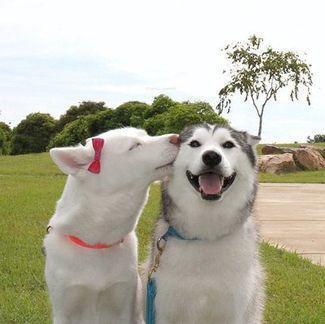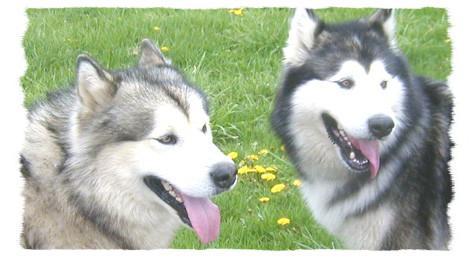The first image is the image on the left, the second image is the image on the right. Considering the images on both sides, is "The left and right image contains the same number of dogs." valid? Answer yes or no. Yes. The first image is the image on the left, the second image is the image on the right. For the images displayed, is the sentence "There are an equal number of dogs in each image." factually correct? Answer yes or no. Yes. 